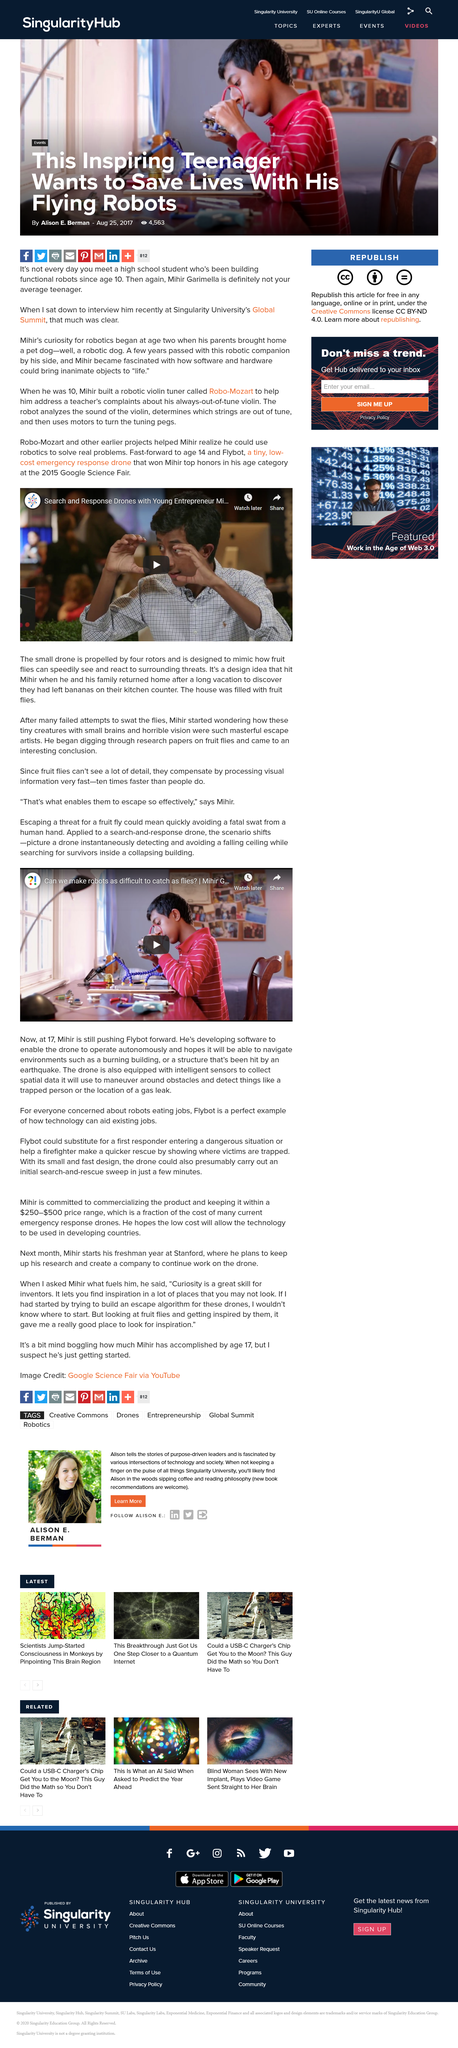Outline some significant characteristics in this image. The small drone is propelled by four rotors. Flybot is a miniature, economical emergency drone designed for rapid deployment in times of crisis. Flybot, a device developed by Mihir, helped him win top honors in his age category at the Google Science Fair in 2015. 